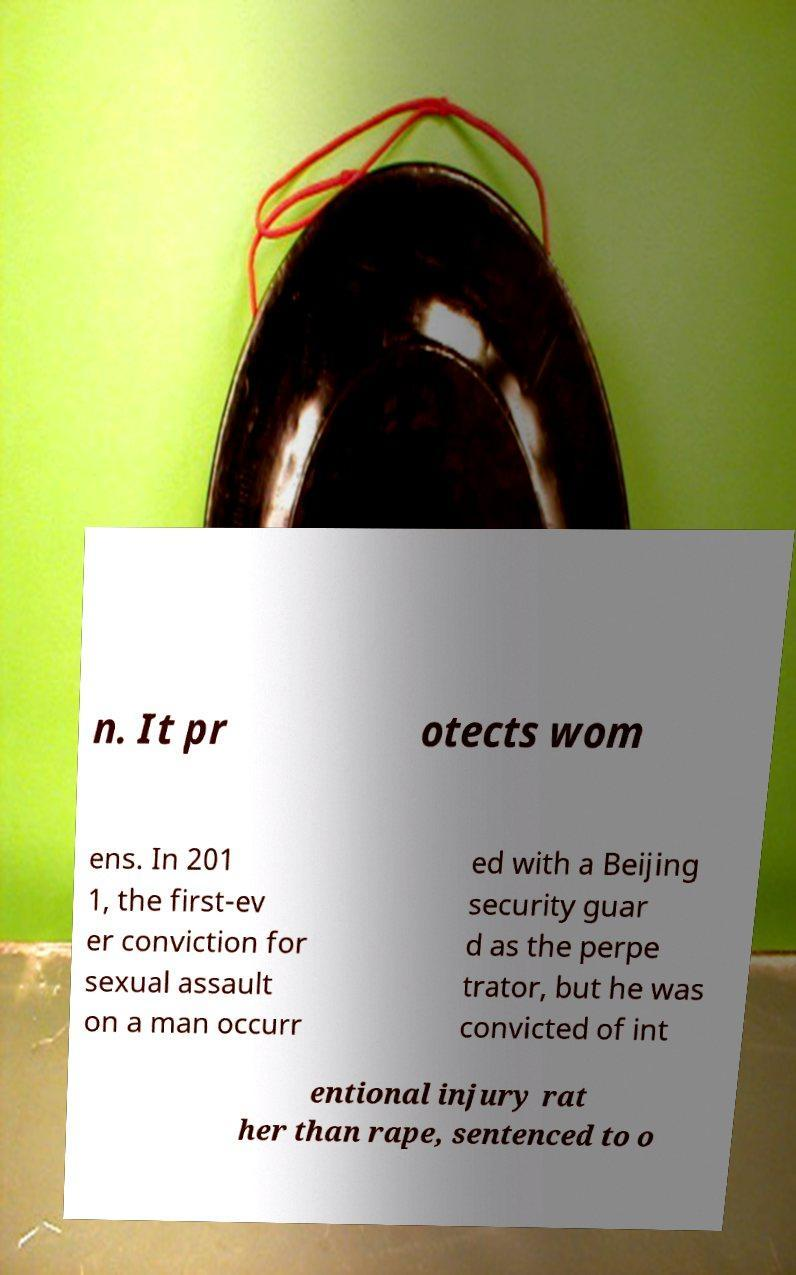For documentation purposes, I need the text within this image transcribed. Could you provide that? n. It pr otects wom ens. In 201 1, the first-ev er conviction for sexual assault on a man occurr ed with a Beijing security guar d as the perpe trator, but he was convicted of int entional injury rat her than rape, sentenced to o 